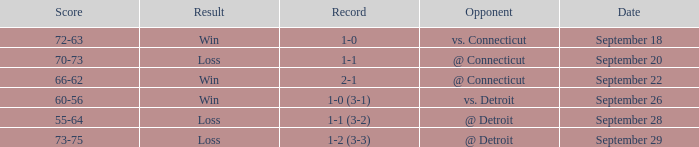WHAT IS THE SCORE WITH A RECORD OF 1-0? 72-63. 